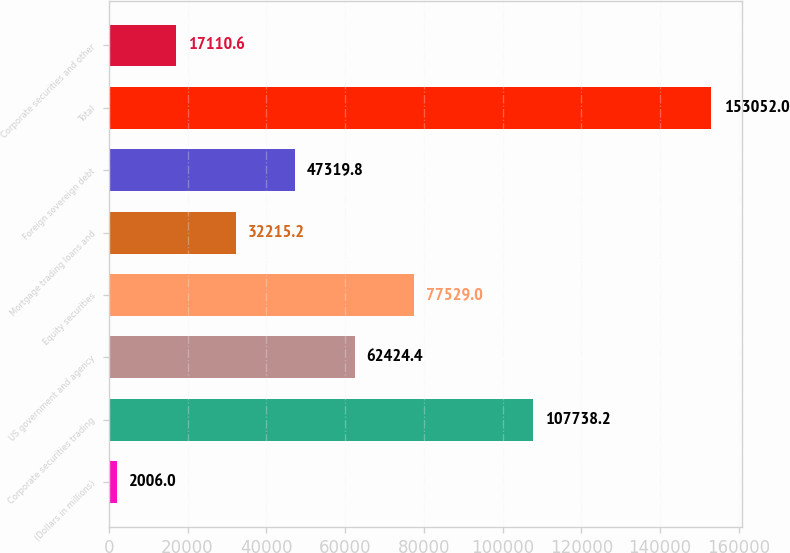<chart> <loc_0><loc_0><loc_500><loc_500><bar_chart><fcel>(Dollars in millions)<fcel>Corporate securities trading<fcel>US government and agency<fcel>Equity securities<fcel>Mortgage trading loans and<fcel>Foreign sovereign debt<fcel>Total<fcel>Corporate securities and other<nl><fcel>2006<fcel>107738<fcel>62424.4<fcel>77529<fcel>32215.2<fcel>47319.8<fcel>153052<fcel>17110.6<nl></chart> 